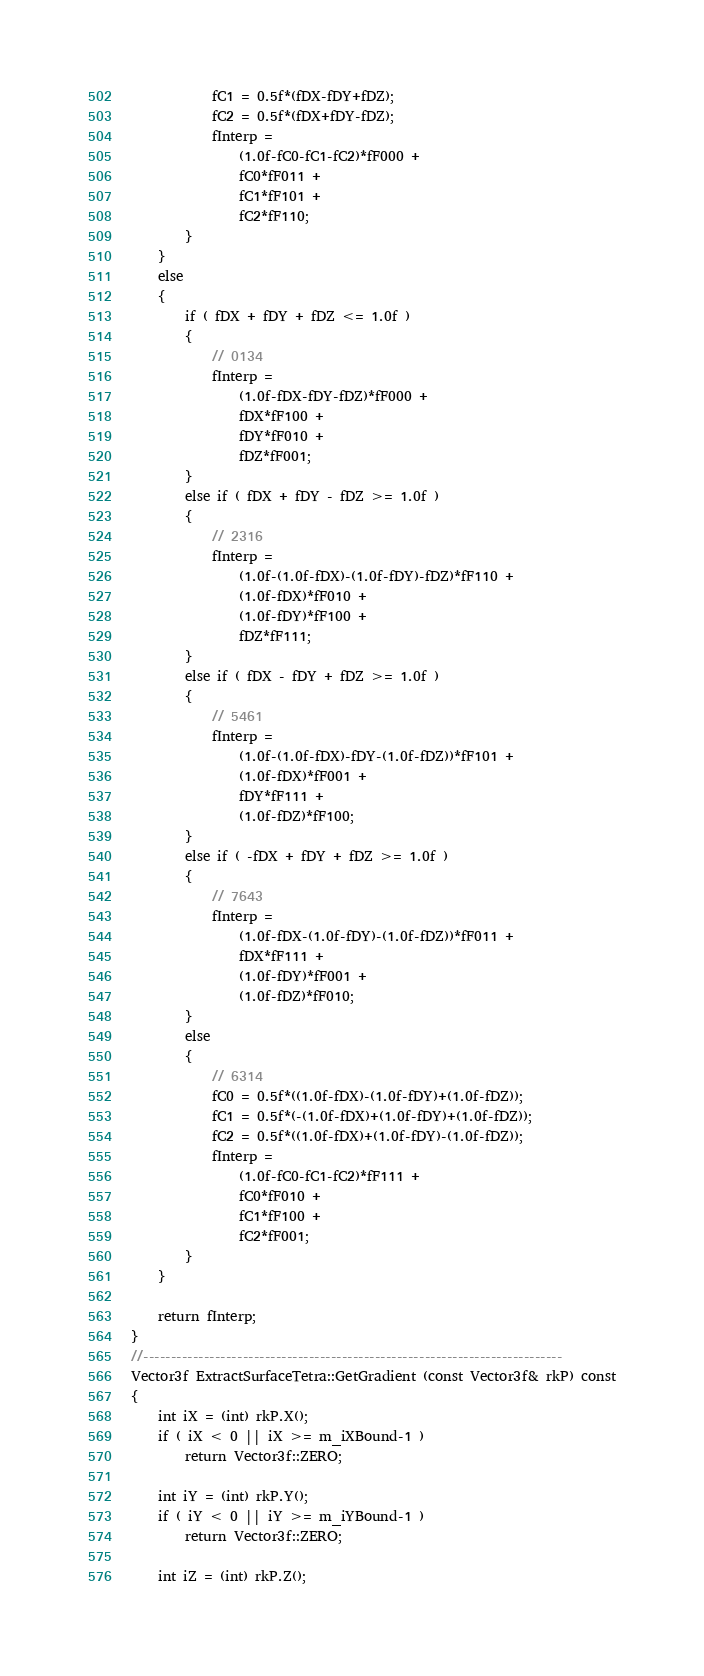Convert code to text. <code><loc_0><loc_0><loc_500><loc_500><_C++_>            fC1 = 0.5f*(fDX-fDY+fDZ);
            fC2 = 0.5f*(fDX+fDY-fDZ);
            fInterp =
                (1.0f-fC0-fC1-fC2)*fF000 +
                fC0*fF011 +
                fC1*fF101 +
                fC2*fF110;
        }
    }
    else
    {
        if ( fDX + fDY + fDZ <= 1.0f )
        {
            // 0134
            fInterp =
                (1.0f-fDX-fDY-fDZ)*fF000 +
                fDX*fF100 +
                fDY*fF010 +
                fDZ*fF001;
        }
        else if ( fDX + fDY - fDZ >= 1.0f )
        {
            // 2316
            fInterp =
                (1.0f-(1.0f-fDX)-(1.0f-fDY)-fDZ)*fF110 +
                (1.0f-fDX)*fF010 +
                (1.0f-fDY)*fF100 +
                fDZ*fF111;
        }
        else if ( fDX - fDY + fDZ >= 1.0f )
        {
            // 5461
            fInterp =
                (1.0f-(1.0f-fDX)-fDY-(1.0f-fDZ))*fF101 +
                (1.0f-fDX)*fF001 +
                fDY*fF111 +
                (1.0f-fDZ)*fF100;
        }
        else if ( -fDX + fDY + fDZ >= 1.0f )
        {
            // 7643
            fInterp =
                (1.0f-fDX-(1.0f-fDY)-(1.0f-fDZ))*fF011 +
                fDX*fF111 +
                (1.0f-fDY)*fF001 +
                (1.0f-fDZ)*fF010;
        }
        else
        {
            // 6314
            fC0 = 0.5f*((1.0f-fDX)-(1.0f-fDY)+(1.0f-fDZ));
            fC1 = 0.5f*(-(1.0f-fDX)+(1.0f-fDY)+(1.0f-fDZ));
            fC2 = 0.5f*((1.0f-fDX)+(1.0f-fDY)-(1.0f-fDZ));
            fInterp =
                (1.0f-fC0-fC1-fC2)*fF111 +
                fC0*fF010 +
                fC1*fF100 +
                fC2*fF001;
        }
    }

    return fInterp;
}
//----------------------------------------------------------------------------
Vector3f ExtractSurfaceTetra::GetGradient (const Vector3f& rkP) const
{
    int iX = (int) rkP.X();
    if ( iX < 0 || iX >= m_iXBound-1 )
        return Vector3f::ZERO;

    int iY = (int) rkP.Y();
    if ( iY < 0 || iY >= m_iYBound-1 )
        return Vector3f::ZERO;

    int iZ = (int) rkP.Z();</code> 